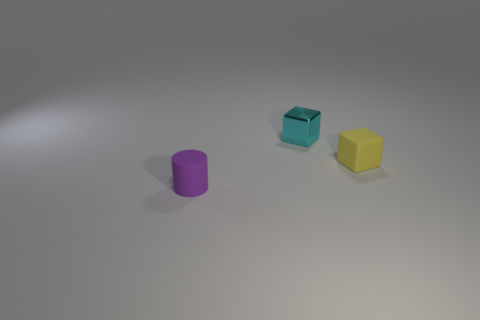How big is the rubber object that is in front of the tiny yellow block?
Give a very brief answer. Small. There is a tiny matte object left of the block in front of the object behind the tiny yellow cube; what shape is it?
Ensure brevity in your answer.  Cylinder. How many other objects are there of the same shape as the small purple thing?
Your answer should be very brief. 0. What number of metal things are cubes or yellow blocks?
Offer a terse response. 1. What is the tiny thing left of the thing behind the yellow rubber block made of?
Offer a terse response. Rubber. Is the number of tiny yellow cubes behind the small metal block greater than the number of tiny yellow rubber blocks?
Your response must be concise. No. Is there a tiny gray sphere that has the same material as the yellow object?
Provide a succinct answer. No. Is the shape of the tiny thing behind the yellow thing the same as  the purple matte object?
Provide a short and direct response. No. There is a object that is in front of the small matte thing that is right of the purple cylinder; what number of things are behind it?
Offer a terse response. 2. Is the number of small purple objects on the right side of the matte block less than the number of tiny yellow objects that are behind the cyan metallic cube?
Your answer should be compact. No. 